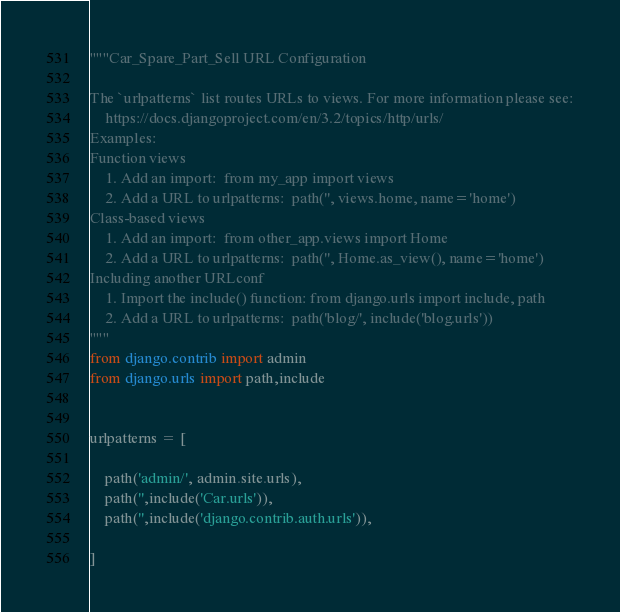Convert code to text. <code><loc_0><loc_0><loc_500><loc_500><_Python_>"""Car_Spare_Part_Sell URL Configuration

The `urlpatterns` list routes URLs to views. For more information please see:
    https://docs.djangoproject.com/en/3.2/topics/http/urls/
Examples:
Function views
    1. Add an import:  from my_app import views
    2. Add a URL to urlpatterns:  path('', views.home, name='home')
Class-based views
    1. Add an import:  from other_app.views import Home
    2. Add a URL to urlpatterns:  path('', Home.as_view(), name='home')
Including another URLconf
    1. Import the include() function: from django.urls import include, path
    2. Add a URL to urlpatterns:  path('blog/', include('blog.urls'))
"""
from django.contrib import admin
from django.urls import path,include


urlpatterns = [

    path('admin/', admin.site.urls),
    path('',include('Car.urls')),
    path('',include('django.contrib.auth.urls')),

]
</code> 